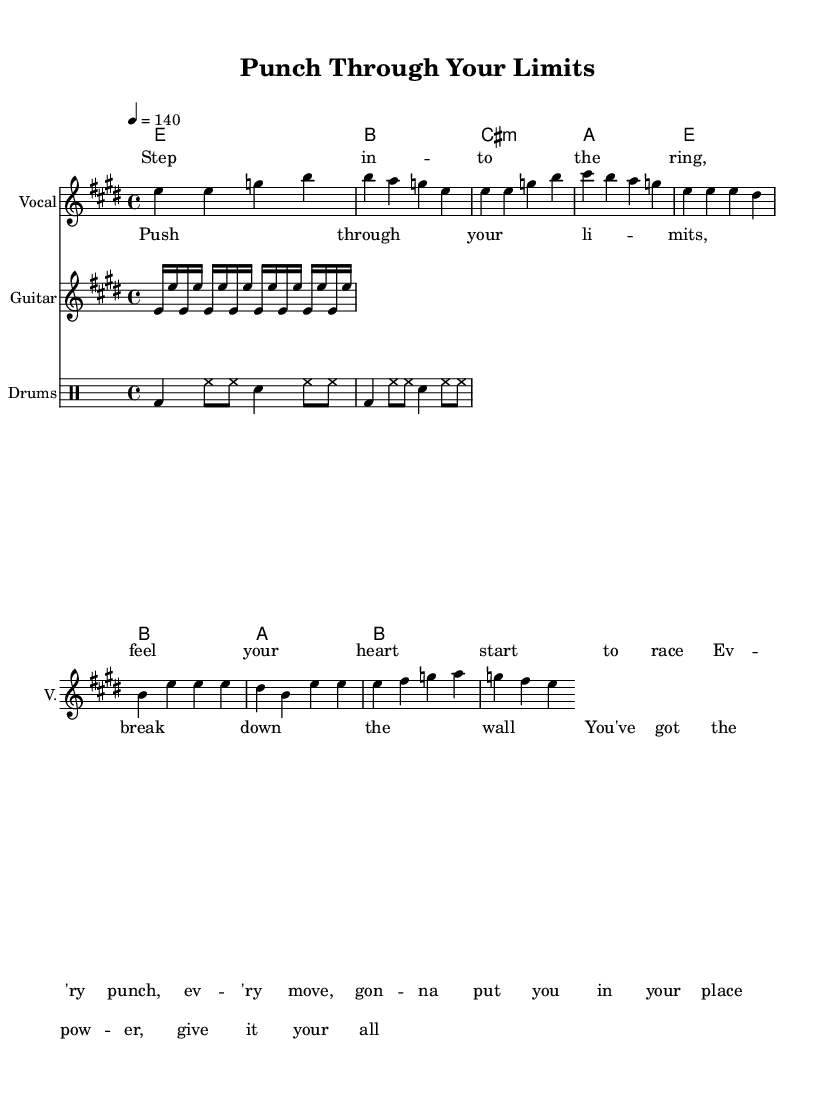What is the key signature of this music? The key signature is E major, which has four sharps: F#, C#, G#, and D#.
Answer: E major What is the time signature of this music? The time signature is 4/4, indicating four beats per measure.
Answer: 4/4 What is the tempo marking in beats per minute? The tempo marking is 140 beats per minute, indicated by "4 = 140."
Answer: 140 How many measures are in the chorus? The chorus consists of four measures based on the notation, shown by the structure of the melody and aligned with the lyrics.
Answer: 4 What are the repeating elements in the guitar riff? The guitar riff features a repeated sequence of E notes in different octaves, illustrating an upbeat and energetic feel characteristic of rock music.
Answer: E What is the primary theme expressed in the chorus lyrics? The primary theme of the chorus focusing on physical fitness and determination is to "Push through your limits." This suggests overcoming challenges and giving maximum effort.
Answer: Push through your limits What is the role of the drums in this piece? The drum pattern provides a consistent rhythm and drive, enhancing the energetic feel of the piece and supporting the forward motion characteristic of rock tracks.
Answer: Drive and support 